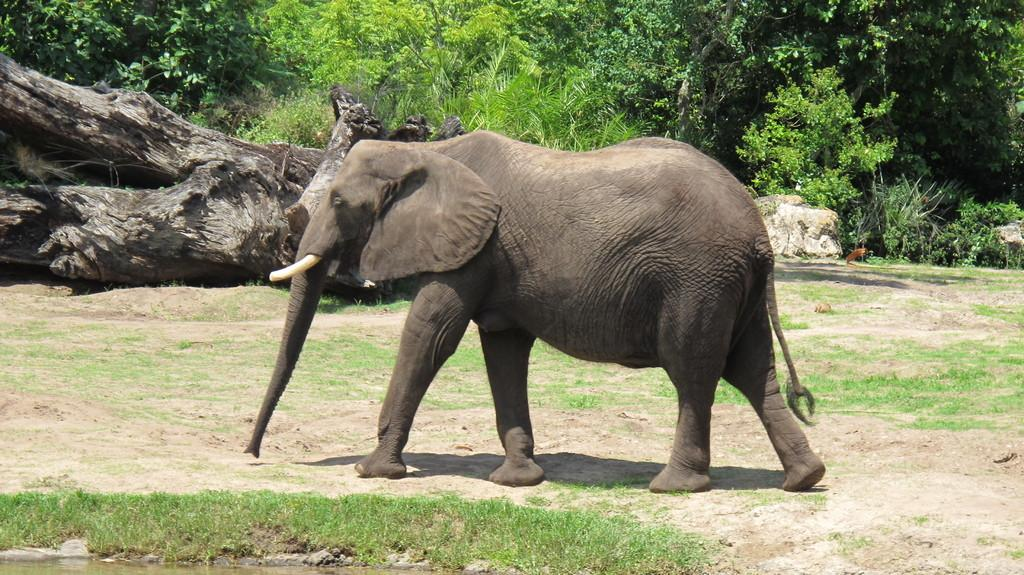What animal is present on the ground in the image? There is an elephant on the ground in the image. What type of vegetation can be seen in the image? There is grass, plants, and trees visible in the image. What is the terrain like in the image? There is a rock and water visible at the bottom of the image. What type of reward is the elephant receiving in the image? There is no indication in the image that the elephant is receiving a reward, so it cannot be determined from the picture. 